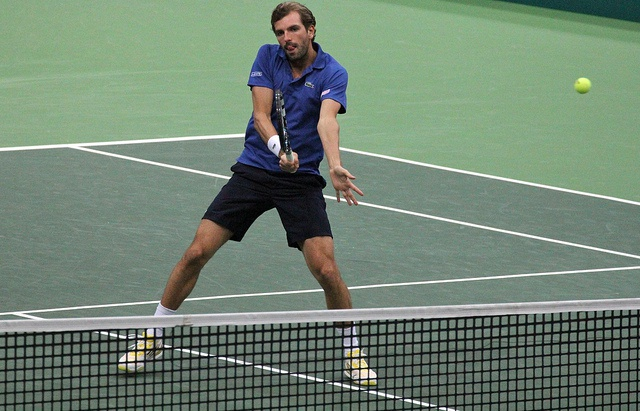Describe the objects in this image and their specific colors. I can see people in darkgray, black, navy, and gray tones, tennis racket in darkgray, black, gray, and navy tones, and sports ball in darkgray, khaki, and lightgreen tones in this image. 